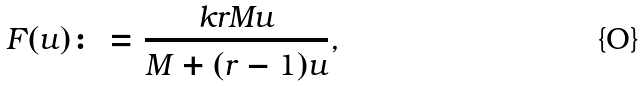Convert formula to latex. <formula><loc_0><loc_0><loc_500><loc_500>F ( u ) \colon = \frac { k r M u } { M + ( r - 1 ) u } ,</formula> 